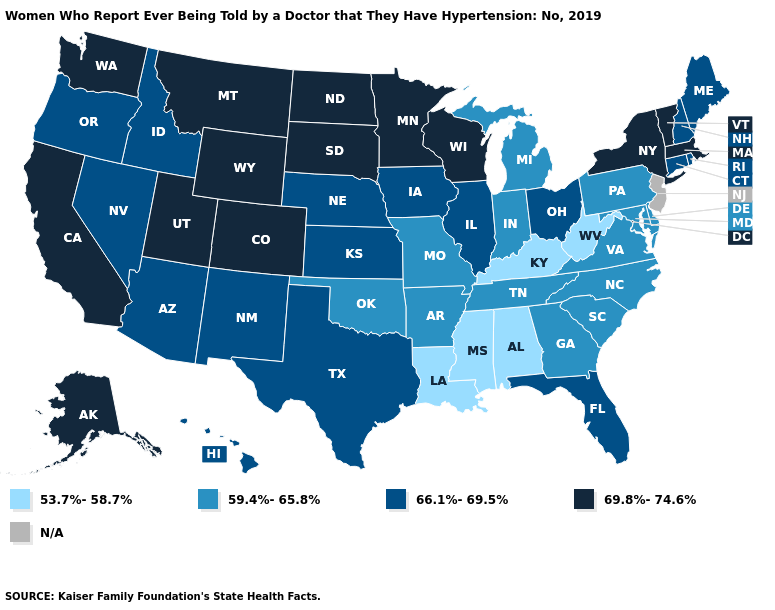Among the states that border Pennsylvania , which have the lowest value?
Quick response, please. West Virginia. Name the states that have a value in the range 66.1%-69.5%?
Give a very brief answer. Arizona, Connecticut, Florida, Hawaii, Idaho, Illinois, Iowa, Kansas, Maine, Nebraska, Nevada, New Hampshire, New Mexico, Ohio, Oregon, Rhode Island, Texas. Which states hav the highest value in the MidWest?
Short answer required. Minnesota, North Dakota, South Dakota, Wisconsin. What is the value of Kansas?
Keep it brief. 66.1%-69.5%. Which states have the lowest value in the USA?
Short answer required. Alabama, Kentucky, Louisiana, Mississippi, West Virginia. What is the value of Rhode Island?
Keep it brief. 66.1%-69.5%. Does Georgia have the highest value in the USA?
Short answer required. No. Is the legend a continuous bar?
Keep it brief. No. Among the states that border California , which have the lowest value?
Short answer required. Arizona, Nevada, Oregon. Name the states that have a value in the range 53.7%-58.7%?
Be succinct. Alabama, Kentucky, Louisiana, Mississippi, West Virginia. Does New Hampshire have the highest value in the USA?
Concise answer only. No. What is the highest value in the USA?
Concise answer only. 69.8%-74.6%. 